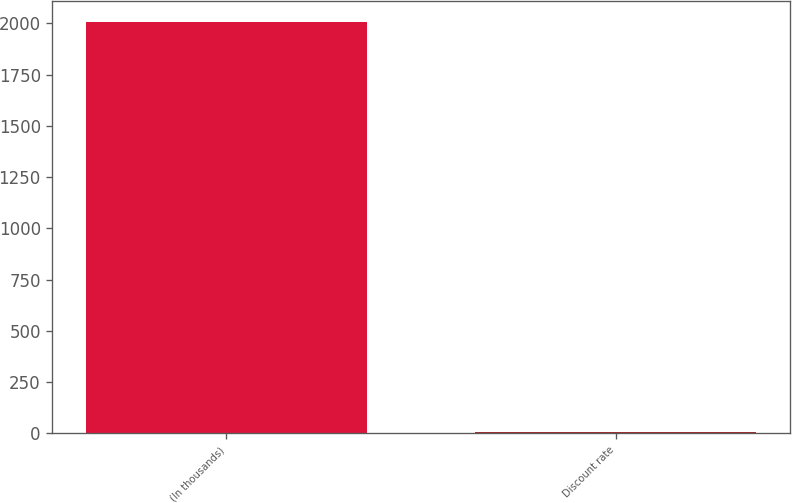Convert chart to OTSL. <chart><loc_0><loc_0><loc_500><loc_500><bar_chart><fcel>(In thousands)<fcel>Discount rate<nl><fcel>2006<fcel>5.75<nl></chart> 